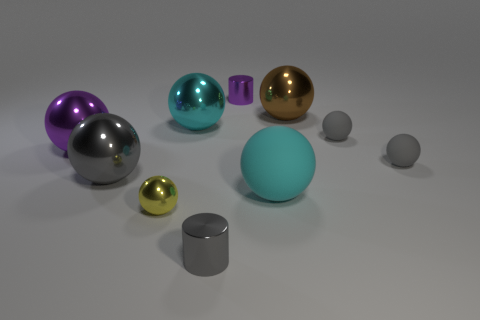The purple metal thing that is the same size as the gray cylinder is what shape?
Your answer should be very brief. Cylinder. There is a large object that is the same color as the big rubber sphere; what material is it?
Keep it short and to the point. Metal. There is a large purple sphere; are there any balls behind it?
Your response must be concise. Yes. There is a big gray ball behind the tiny cylinder that is in front of the large cyan metallic ball; what is it made of?
Your answer should be compact. Metal. What is the size of the gray shiny object that is the same shape as the small yellow object?
Provide a succinct answer. Large. Is the large matte object the same color as the tiny metal sphere?
Ensure brevity in your answer.  No. There is a small metal thing that is both behind the small gray metal cylinder and in front of the large cyan metal sphere; what color is it?
Offer a terse response. Yellow. Is the size of the shiny ball on the right side of the gray metallic cylinder the same as the yellow ball?
Provide a short and direct response. No. Is there any other thing that is the same shape as the tiny purple metallic object?
Your answer should be very brief. Yes. Are the yellow sphere and the large cyan object that is left of the big cyan rubber object made of the same material?
Keep it short and to the point. Yes. 